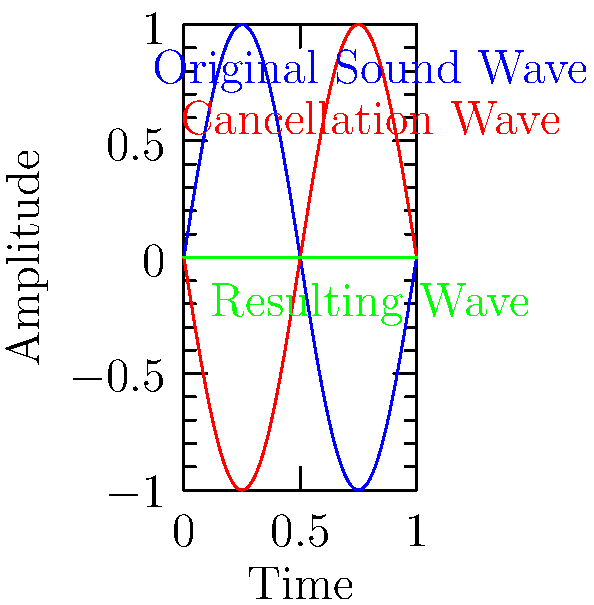In an active noise cancellation system for reducing machine noise in a manufacturing plant, what is the phase relationship between the original sound wave and the cancellation wave to achieve maximum noise reduction? To understand the phase relationship for maximum noise reduction in an active noise cancellation system:

1. Active noise cancellation works on the principle of destructive interference.

2. Destructive interference occurs when two waves of equal amplitude are 180 degrees out of phase.

3. In the diagram:
   - The blue curve represents the original sound wave.
   - The red curve represents the cancellation wave.
   - The green curve shows the resulting wave after interference.

4. Observe that the red curve (cancellation wave) is an inverted version of the blue curve (original sound wave).

5. This inversion represents a phase shift of 180 degrees or $\pi$ radians.

6. When these waves are combined, they cancel each other out, resulting in the flat green line (zero amplitude).

7. Mathematically, this can be expressed as:
   Original wave: $A \sin(\omega t)$
   Cancellation wave: $-A \sin(\omega t)$ or $A \sin(\omega t + \pi)$

8. The sum of these waves: $A \sin(\omega t) + A \sin(\omega t + \pi) = 0$

Therefore, for maximum noise reduction, the cancellation wave should be 180 degrees out of phase with the original sound wave.
Answer: 180 degrees out of phase 